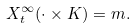Convert formula to latex. <formula><loc_0><loc_0><loc_500><loc_500>X _ { t } ^ { \infty } ( \cdot \times K ) = m .</formula> 